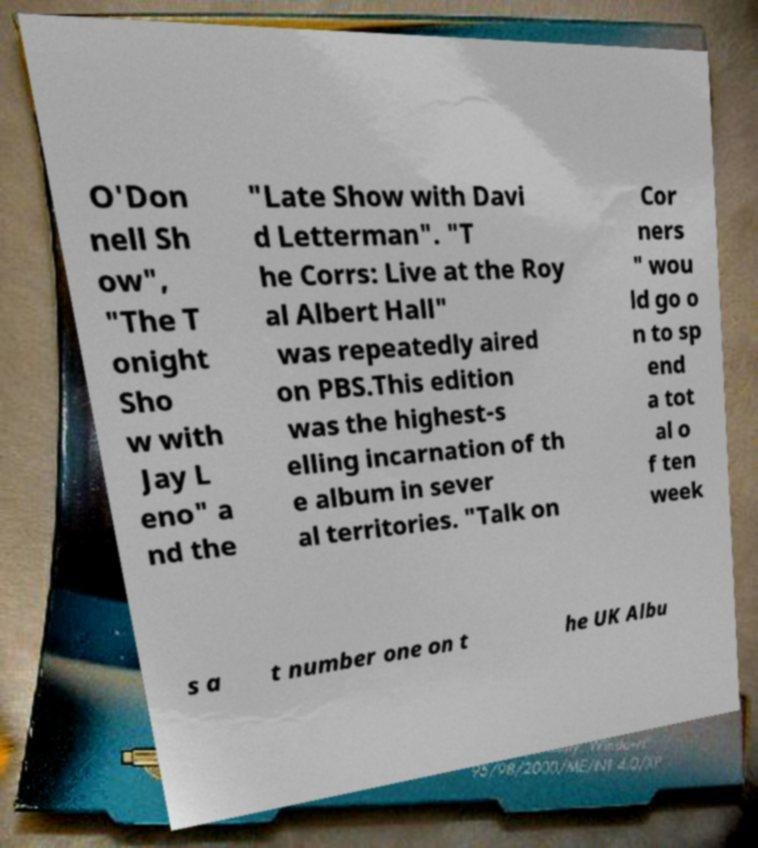Please read and relay the text visible in this image. What does it say? O'Don nell Sh ow", "The T onight Sho w with Jay L eno" a nd the "Late Show with Davi d Letterman". "T he Corrs: Live at the Roy al Albert Hall" was repeatedly aired on PBS.This edition was the highest-s elling incarnation of th e album in sever al territories. "Talk on Cor ners " wou ld go o n to sp end a tot al o f ten week s a t number one on t he UK Albu 